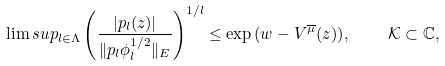Convert formula to latex. <formula><loc_0><loc_0><loc_500><loc_500>\lim s u p _ { l \in \Lambda } \left ( \frac { | p _ { l } ( z ) | } { \| p _ { l } \phi _ { l } ^ { 1 / 2 } \| _ { E } } \right ) ^ { 1 / l } \leq \exp { ( w - V ^ { \overline { \mu } } ( z ) ) } , \quad \mathcal { K } \subset { \mathbb { C } } ,</formula> 